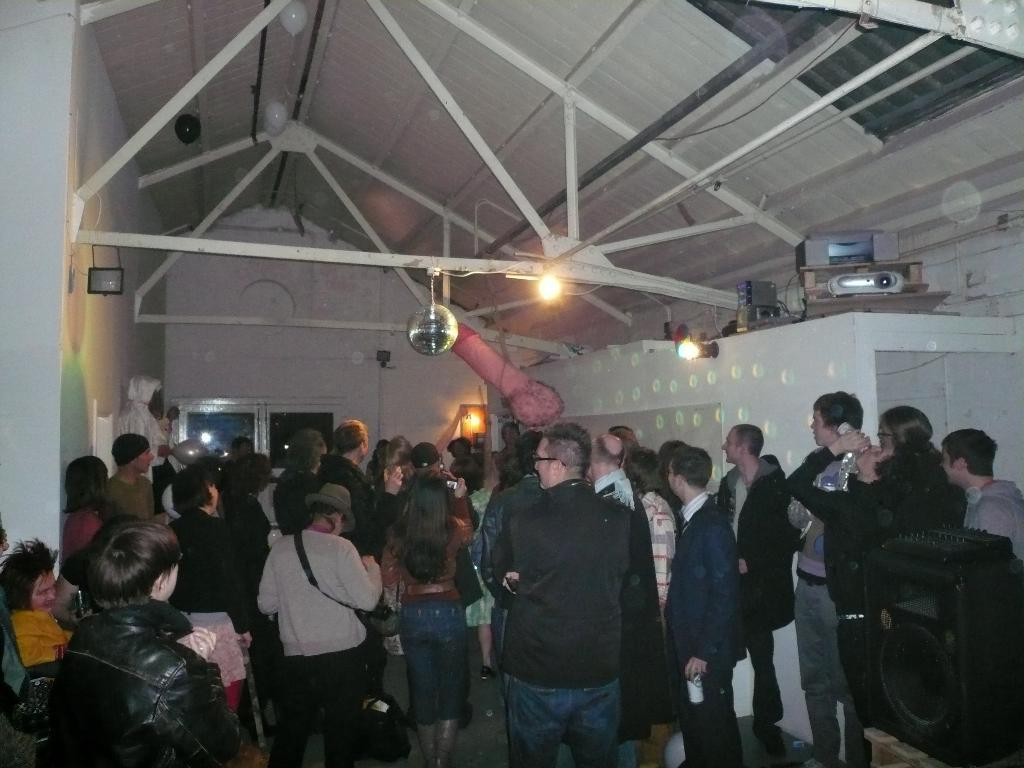How many people are in the group visible in the image? There is a group of people in the image, but the exact number is not specified. What are the people in the image doing? The people are standing in the image. What can be seen in the middle of the image? There is a light in the middle of the image. What type of structure is visible in the image? There is a roof visible in the image. Can you see any discussions taking place among the people in the image? The image does not show any discussions taking place among the people; it only shows them standing. Is there a cobweb visible in the image? There is no cobweb visible in the image. 